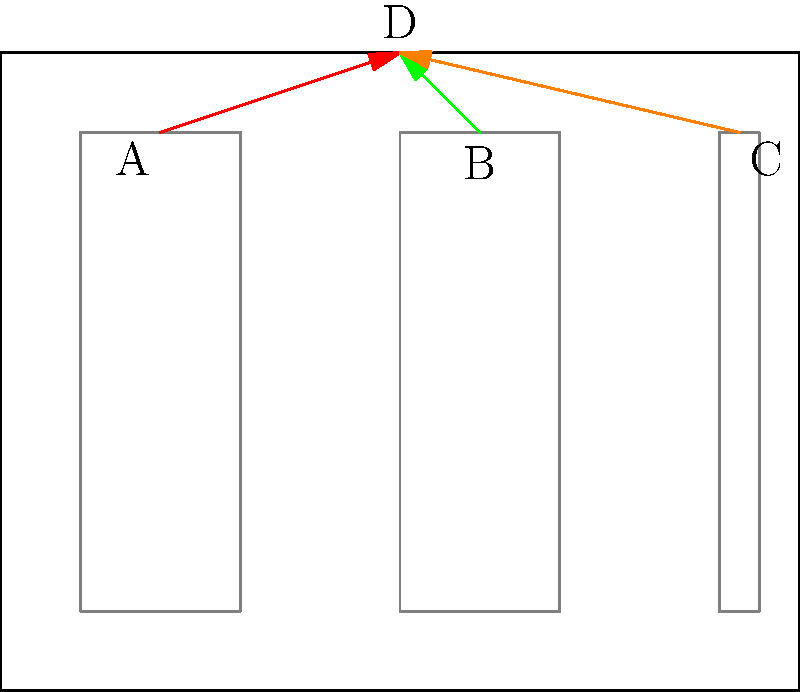In a server room, cables need to be routed from three server racks (A, B, and C) to a central connection point (D). The positions of these points in meters are: A(2,7), B(6,7), C(9.25,7), and D(5,8). What is the total length of cable needed to connect all three server racks to the central point, rounded to the nearest tenth of a meter? To solve this problem, we need to calculate the length of each cable and sum them up. We can use vector algebra to find these lengths.

Step 1: Calculate the vectors from each server rack to the central point.
$$\vec{AD} = (5-2, 8-7) = (3, 1)$$
$$\vec{BD} = (5-6, 8-7) = (-1, 1)$$
$$\vec{CD} = (5-9.25, 8-7) = (-4.25, 1)$$

Step 2: Calculate the magnitude (length) of each vector using the Pythagorean theorem.
Length of AD = $\sqrt{3^2 + 1^2} = \sqrt{10} \approx 3.16$ meters
Length of BD = $\sqrt{(-1)^2 + 1^2} = \sqrt{2} \approx 1.41$ meters
Length of CD = $\sqrt{(-4.25)^2 + 1^2} = \sqrt{19.0625} \approx 4.37$ meters

Step 3: Sum up the lengths of all cables.
Total length = 3.16 + 1.41 + 4.37 = 8.94 meters

Step 4: Round to the nearest tenth of a meter.
8.94 rounds to 8.9 meters

Therefore, the total length of cable needed is approximately 8.9 meters.
Answer: 8.9 meters 